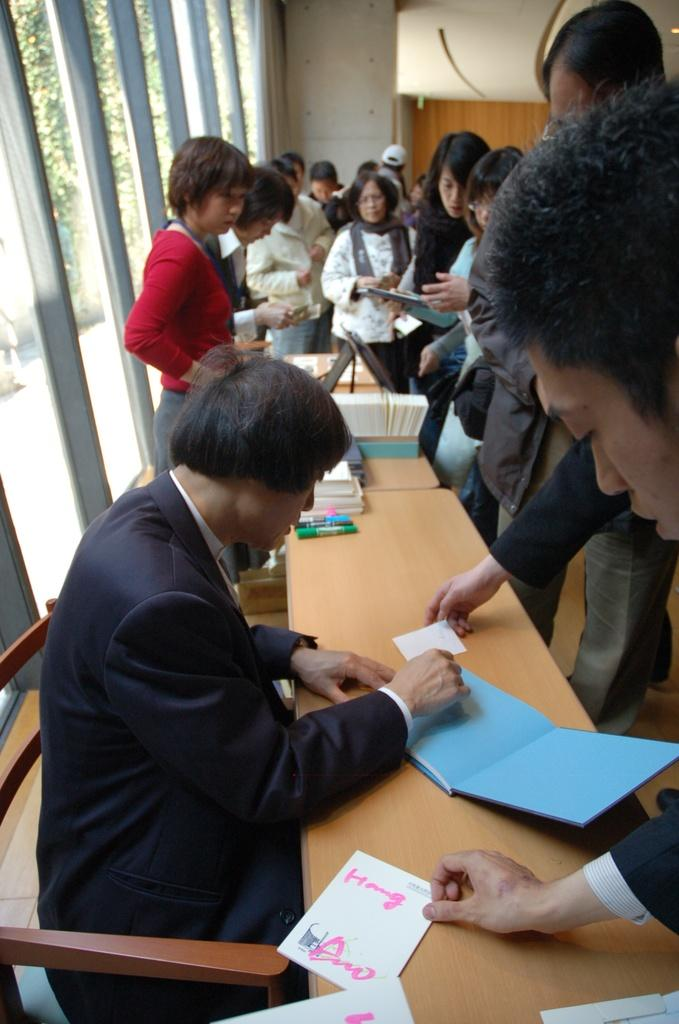What are the people in the image doing? There are people sitting and standing in the image. What objects are on the table in the image? There are papers, sketches, and a book on the table. What type of meal is being prepared in the image? There is no indication of a meal being prepared in the image. What emotion can be seen on the faces of the people in the image? The provided facts do not mention any emotions or facial expressions of the people in the image. 